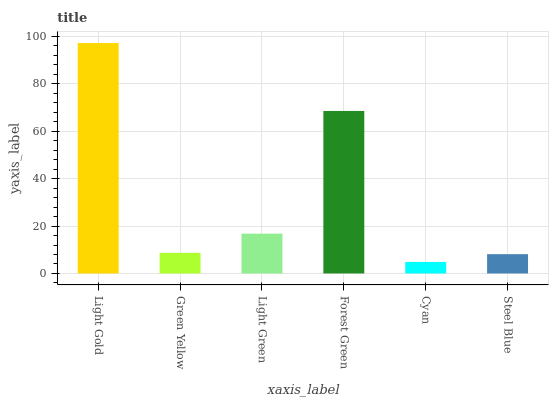Is Cyan the minimum?
Answer yes or no. Yes. Is Light Gold the maximum?
Answer yes or no. Yes. Is Green Yellow the minimum?
Answer yes or no. No. Is Green Yellow the maximum?
Answer yes or no. No. Is Light Gold greater than Green Yellow?
Answer yes or no. Yes. Is Green Yellow less than Light Gold?
Answer yes or no. Yes. Is Green Yellow greater than Light Gold?
Answer yes or no. No. Is Light Gold less than Green Yellow?
Answer yes or no. No. Is Light Green the high median?
Answer yes or no. Yes. Is Green Yellow the low median?
Answer yes or no. Yes. Is Green Yellow the high median?
Answer yes or no. No. Is Forest Green the low median?
Answer yes or no. No. 